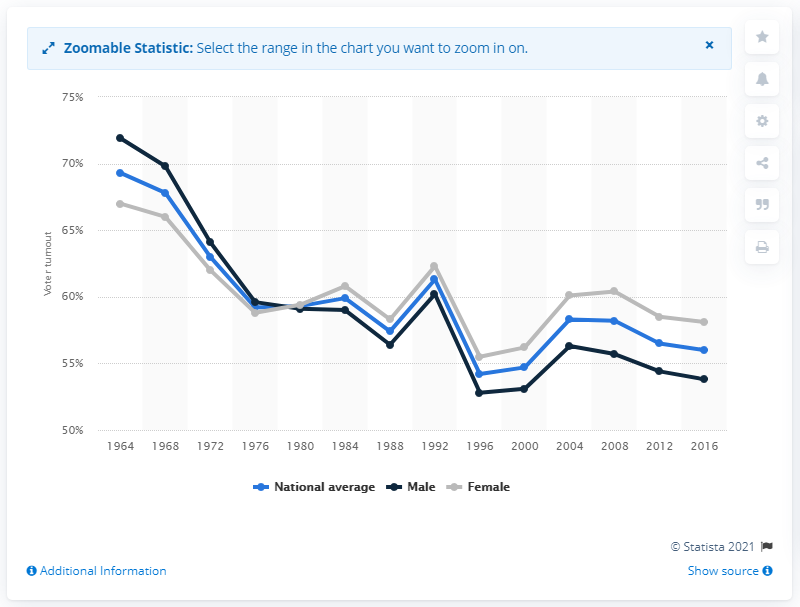Identify some key points in this picture. In the year 1964, the presidential election in the United States was held. 